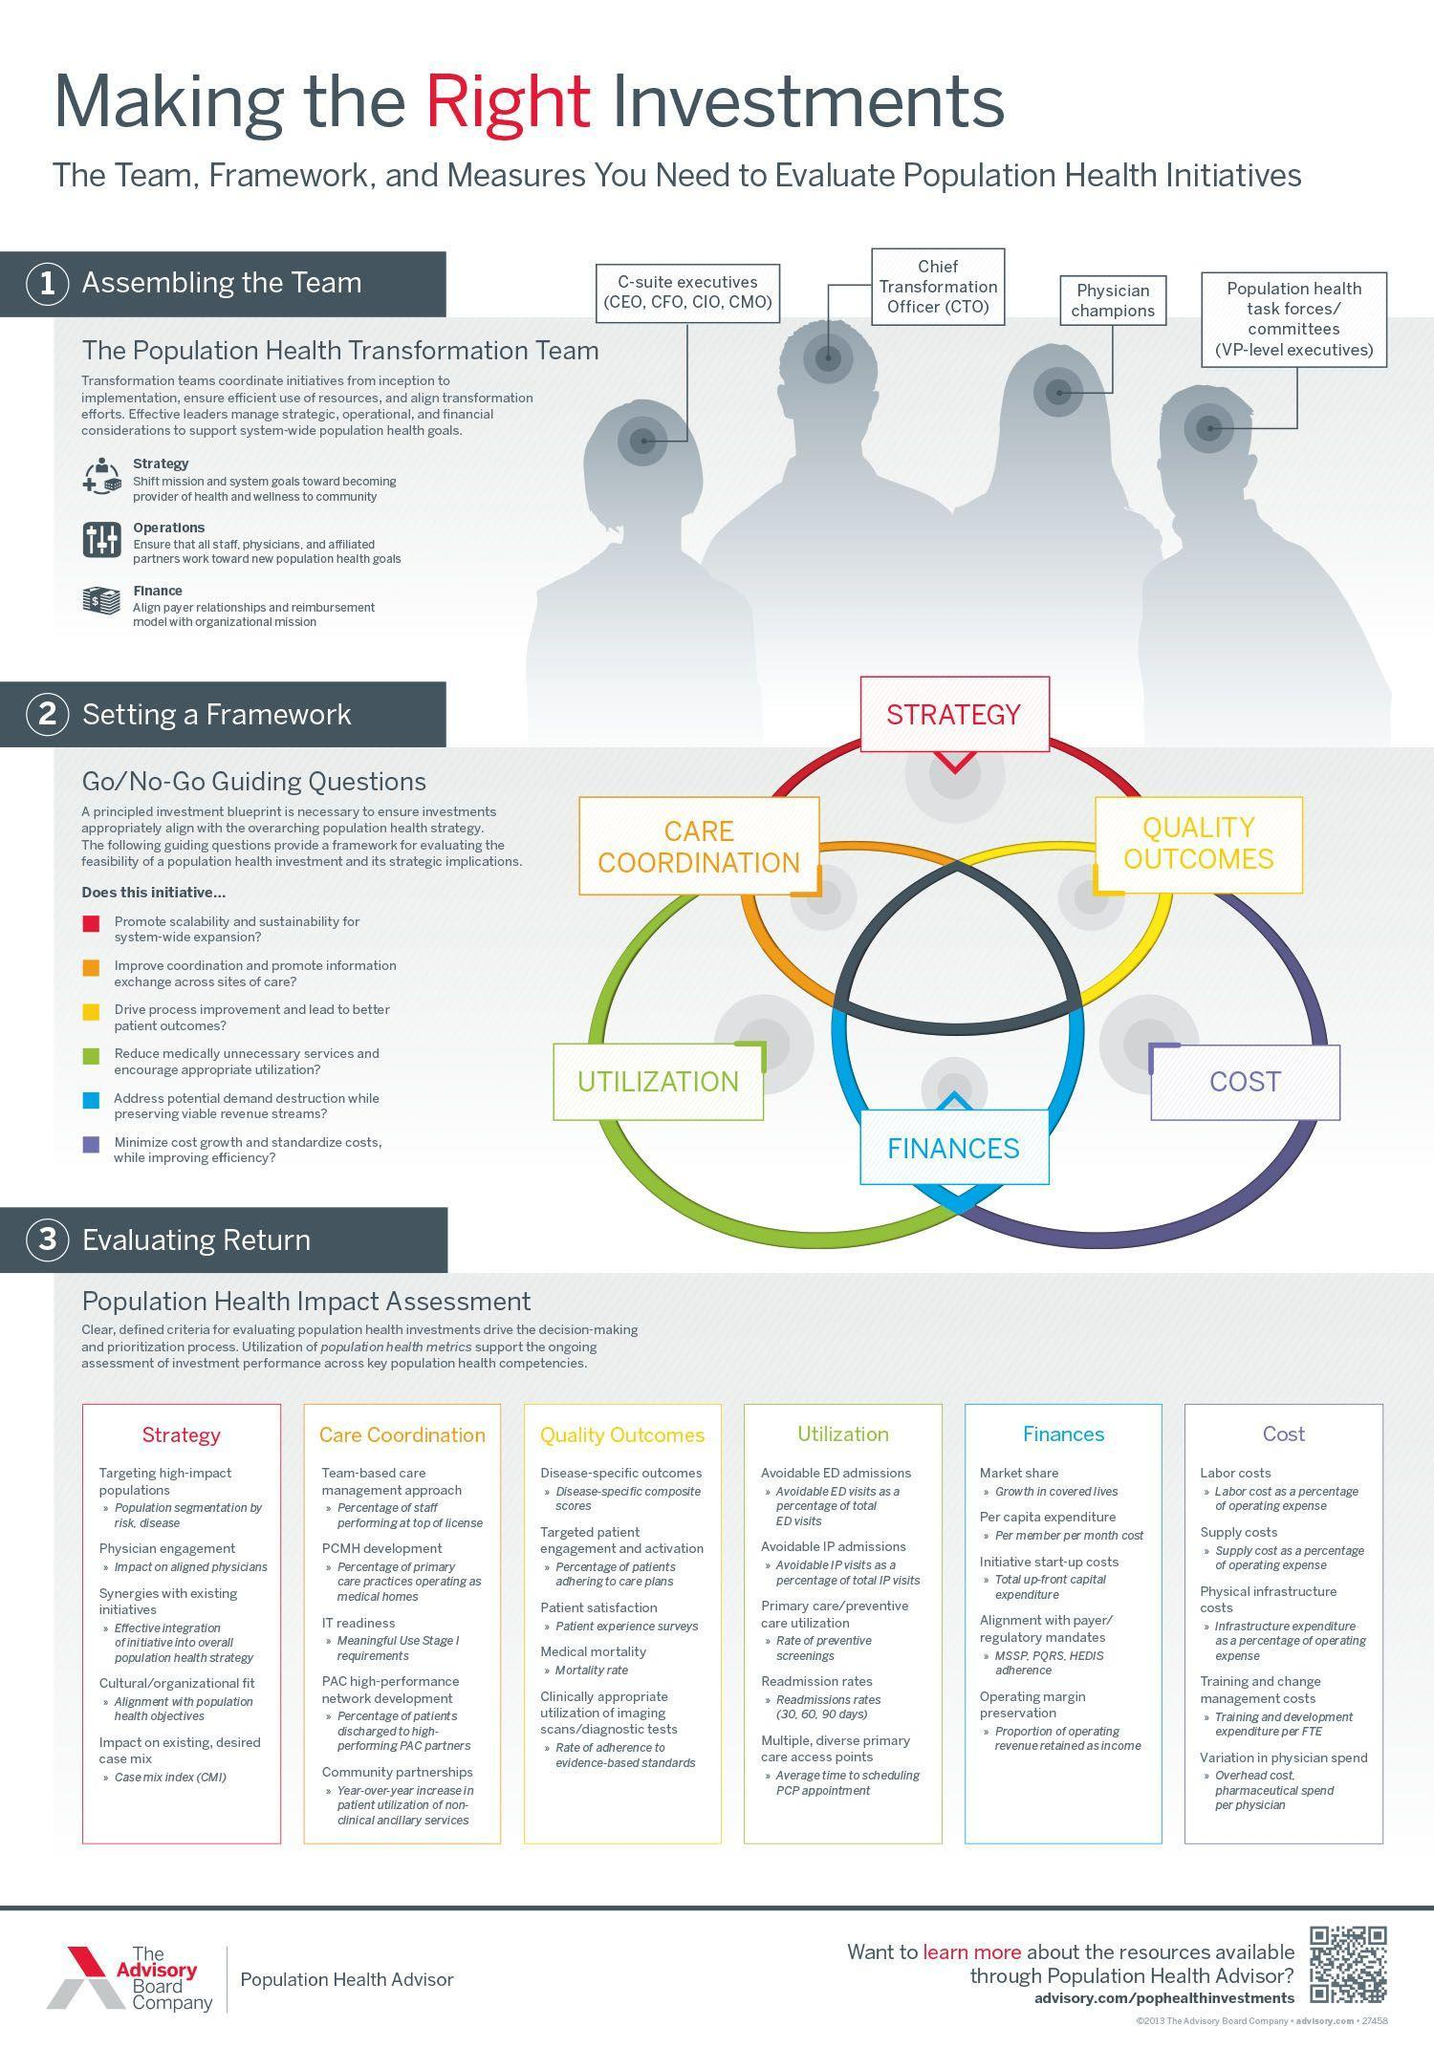How many steps for setting a framework?
Answer the question with a short phrase. 6 How many steps for evaluating return? 6 